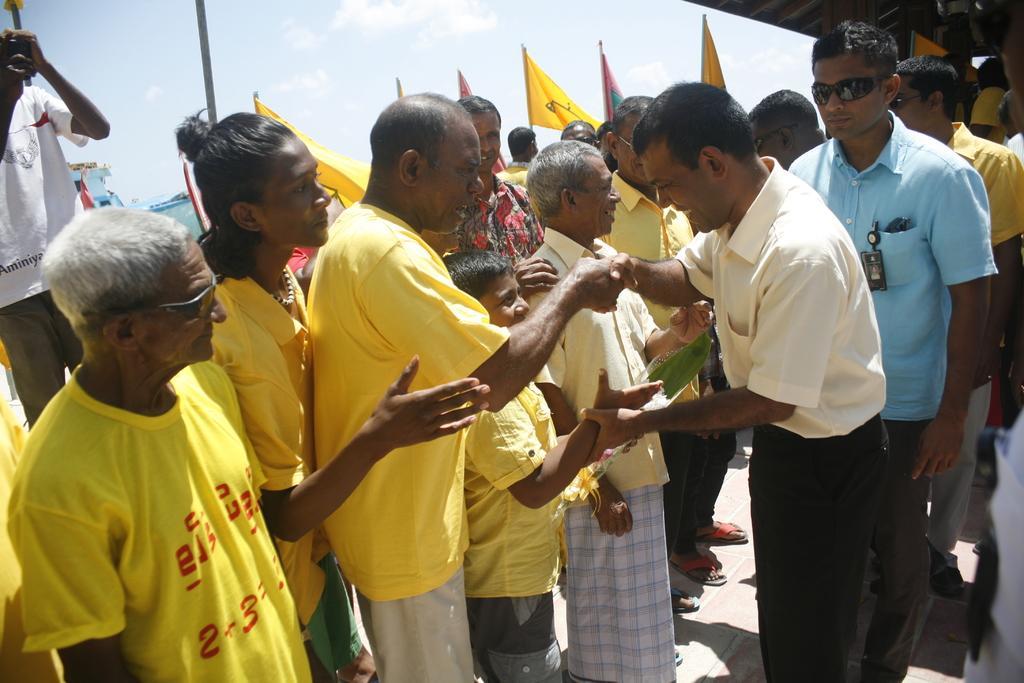Please provide a concise description of this image. In the image we can see there are many people standing and wearing clothes. We can even see there are many flags and this is a pole. We can even see a sky. 